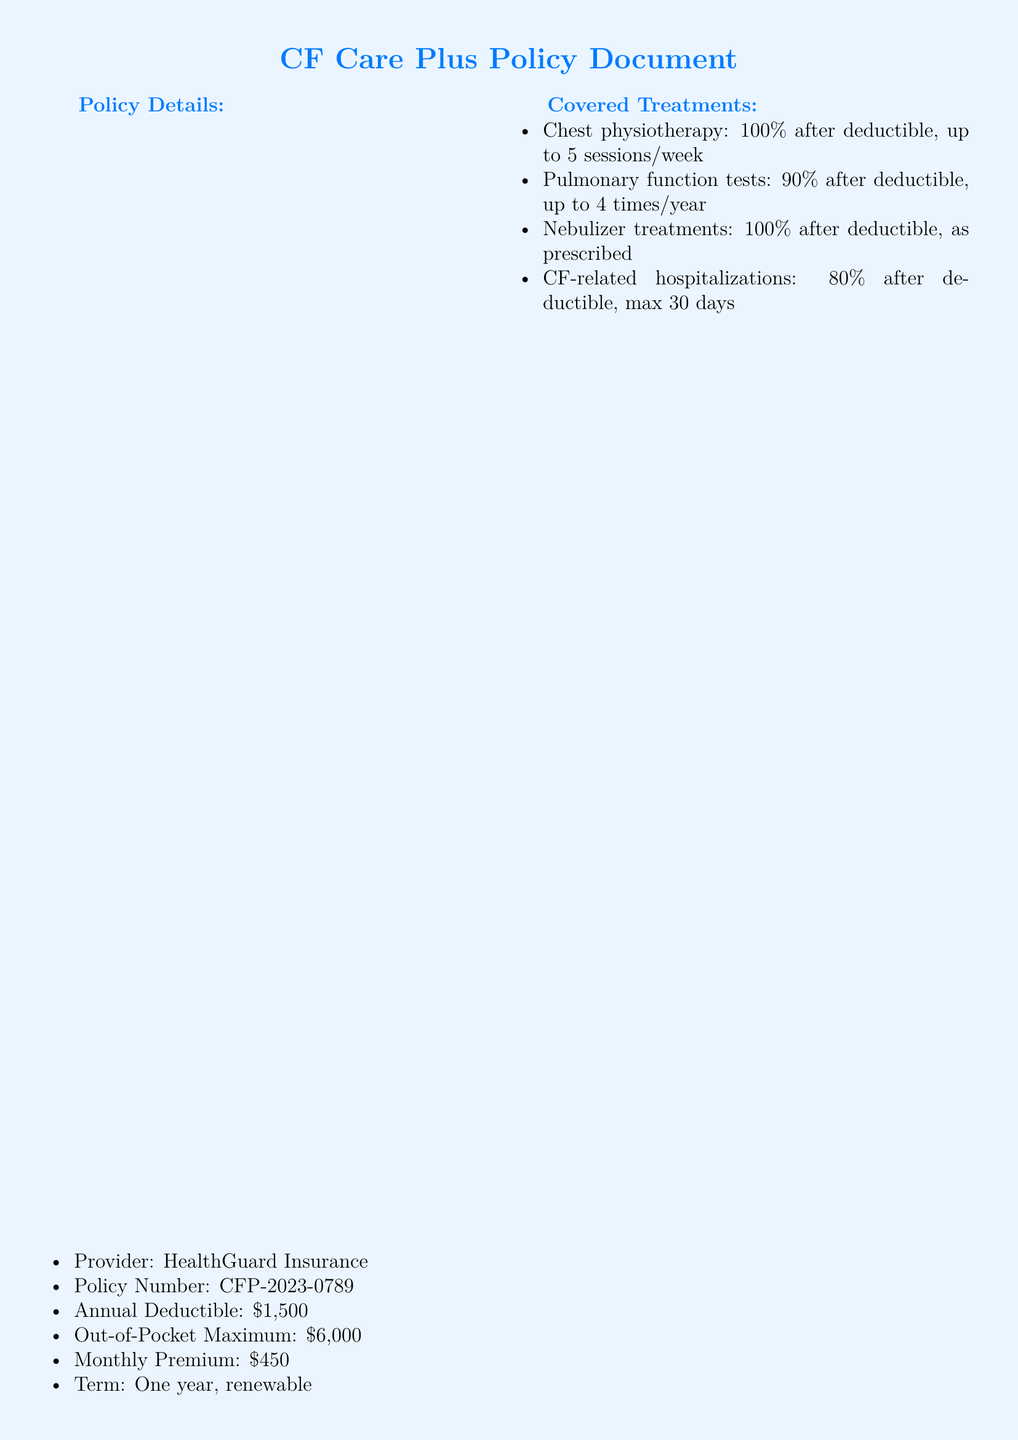What is the provider of the policy? The provider is listed under Policy Details in the document.
Answer: HealthGuard Insurance What is the annual deductible? The annual deductible is specified in the Policy Details section of the document.
Answer: $1,500 What percentage of nebulizer treatments is covered? The coverage percentage for nebulizer treatments is found in the Covered Treatments section.
Answer: 100% How many sessions of chest physiotherapy are covered per week? The maximum number of sessions is stated in the Covered Treatments section.
Answer: 5 sessions/week What is the coverage percentage for Trikafta after the deductible? The coverage percentage is mentioned in the Covered Medications section of the document.
Answer: 90% What is the maximum duration for CF-related hospitalizations coverage? The maximum number of days for hospitalizations is indicated in the Covered Treatments section.
Answer: 30 days What type of specialists can be accessed under special provisions? The type of specialists is indicated in the Special Provisions section.
Answer: CF specialists What is the monthly premium for the policy? The monthly premium is outlined in the Policy Details section.
Answer: $450 What is mentioned in the special notes about the policy? The content of the special notes emphasizes the intent of the policy.
Answer: Comprehensive coverage for essential treatments and medications 